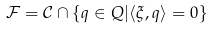Convert formula to latex. <formula><loc_0><loc_0><loc_500><loc_500>\mathcal { F } = \mathcal { C } \cap \{ q \in Q | \langle \xi , q \rangle = 0 \}</formula> 